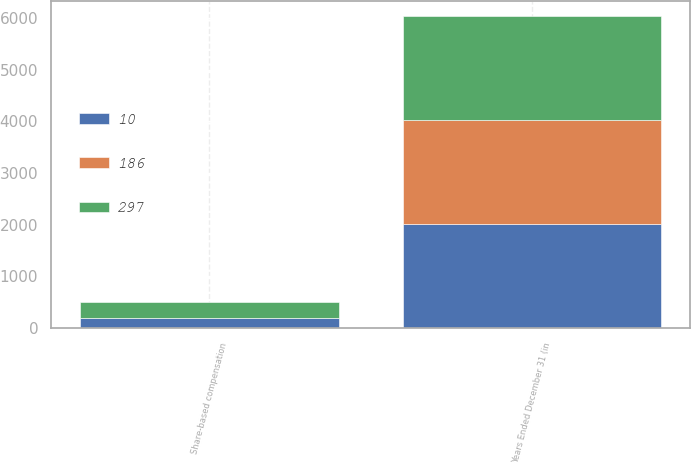Convert chart to OTSL. <chart><loc_0><loc_0><loc_500><loc_500><stacked_bar_chart><ecel><fcel>Years Ended December 31 (in<fcel>Share-based compensation<nl><fcel>297<fcel>2013<fcel>297<nl><fcel>10<fcel>2012<fcel>186<nl><fcel>186<fcel>2011<fcel>10<nl></chart> 